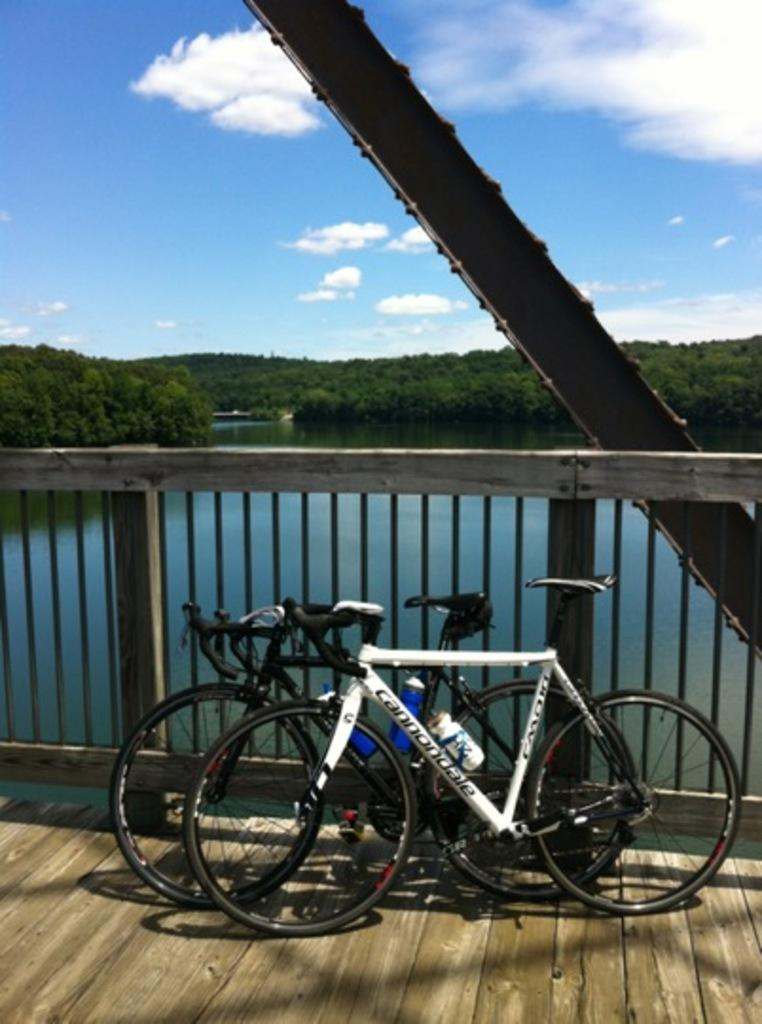What objects are parked on the ground in the image? There are bicycles parked on the ground in the image. What type of barrier can be seen in the image? There are iron railings in the image. What natural element is visible in the image? There is water visible in the image. What type of vegetation is present in the image? There are many trees in the image. What is the condition of the sky in the image? The sky is clear in the image. How many brothers are sitting on the bicycles in the image? There are no brothers present in the image; it only shows bicycles parked on the ground. What type of bag is hanging on the trees in the image? There are no bags hanging on the trees in the image; it only shows trees and other elements mentioned in the facts. 